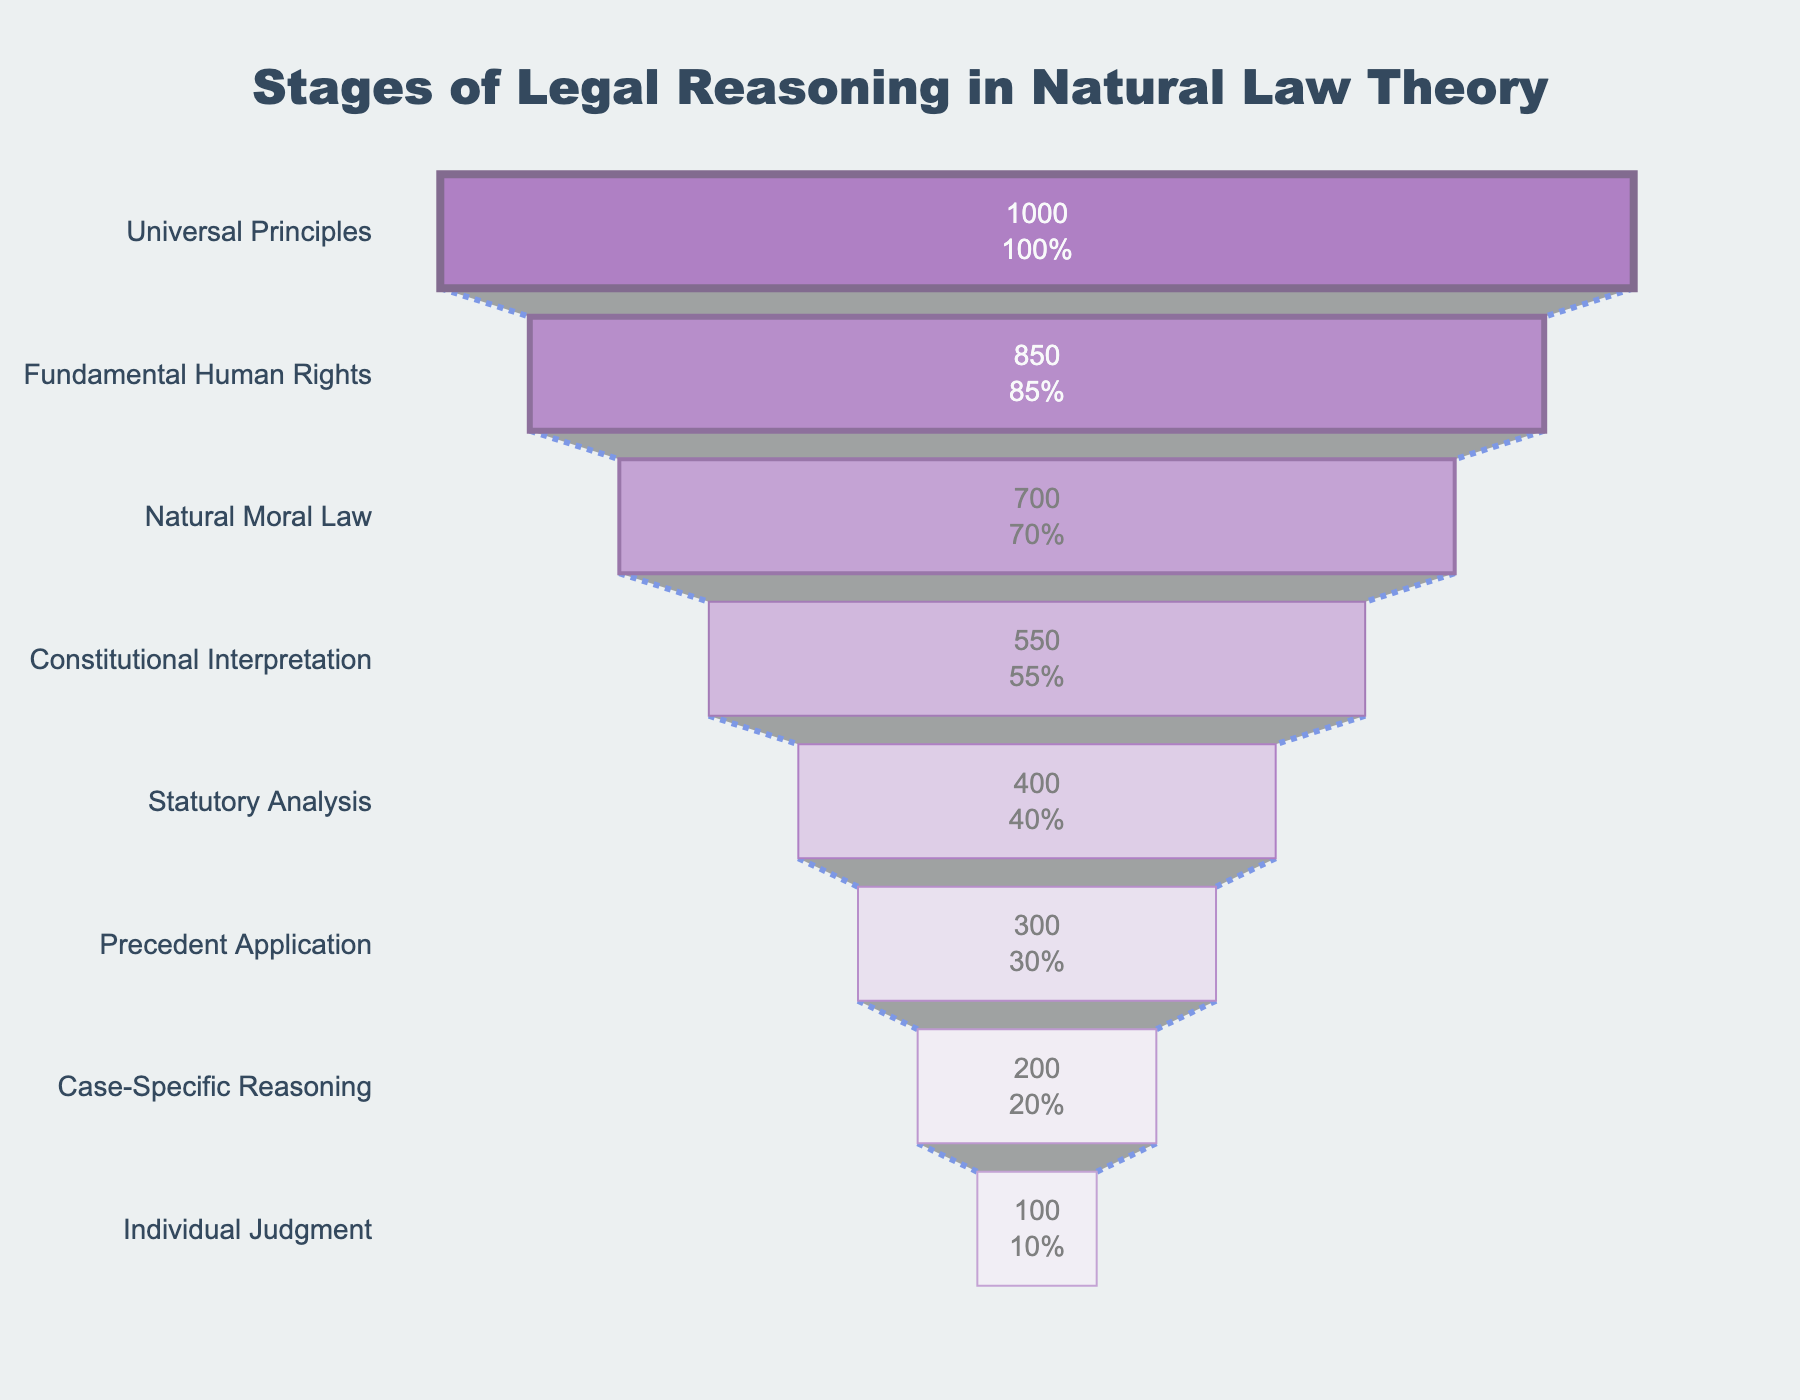What is the title of the funnel chart? The title of the funnel chart is usually positioned at the top of the figure and gives a summary of what the chart represents. In this case, the title is "Stages of Legal Reasoning in Natural Law Theory"
Answer: Stages of Legal Reasoning in Natural Law Theory How many stages of legal reasoning are displayed in the funnel chart? The funnel chart has a vertical list of stages starting from the top to the bottom. Counting these stages will give us the number of stages represented in the chart.
Answer: 8 Which stage has the highest number of cases? The stage at the top of the funnel usually represents the highest number of cases. In this figure, the number is listed explicitly next to the stage.
Answer: Universal Principles At which stage does the number of cases first drop below 500? The chart lists the number of cases for each stage from top to bottom. We need to identify the first stage where the number of cases becomes less than 500.
Answer: Statutory Analysis What percentage of the initial value does the "Case-Specific Reasoning" stage represent? To find the percentage, divide the number of cases in "Case-Specific Reasoning" by the number of cases in the first stage (Universal Principles) and multiply by 100. Therefore, (200/1000) * 100%.
Answer: 20% What is the difference in the number of cases between "Fundamental Human Rights" and "Case-Specific Reasoning"? Subtract the number of cases in "Case-Specific Reasoning" from the number of cases in "Fundamental Human Rights". Thus, 850 - 200.
Answer: 650 Which stage shows a drop of exactly 150 cases from the previous stage? We need to go through each paired stages and subtract the number of cases for accurate identification. Comparing each, "Natural Moral Law" (700) drops to "Constitutional Interpretation" (550), a difference of 150 cases.
Answer: Constitutional Interpretation How many stages represent more than half of the initial number of cases? Half of the initial cases (Universal Principles with 1000 cases) is 500. Count the number of stages with more than 500 cases.
Answer: 3 What color is used for the "Individual Judgment" stage bar? The colors of each stage are visually distinguishable. "Individual Judgment" being the last stage is colored distinctly.
Answer: Light Purple (F5EEF8) How does the width of the lines around the stage bars change from top to bottom? Observe the width of the lines surrounding each stage bar. The lines usually decrease in width from top (4 units) to bottom (1 unit).
Answer: Decreases 